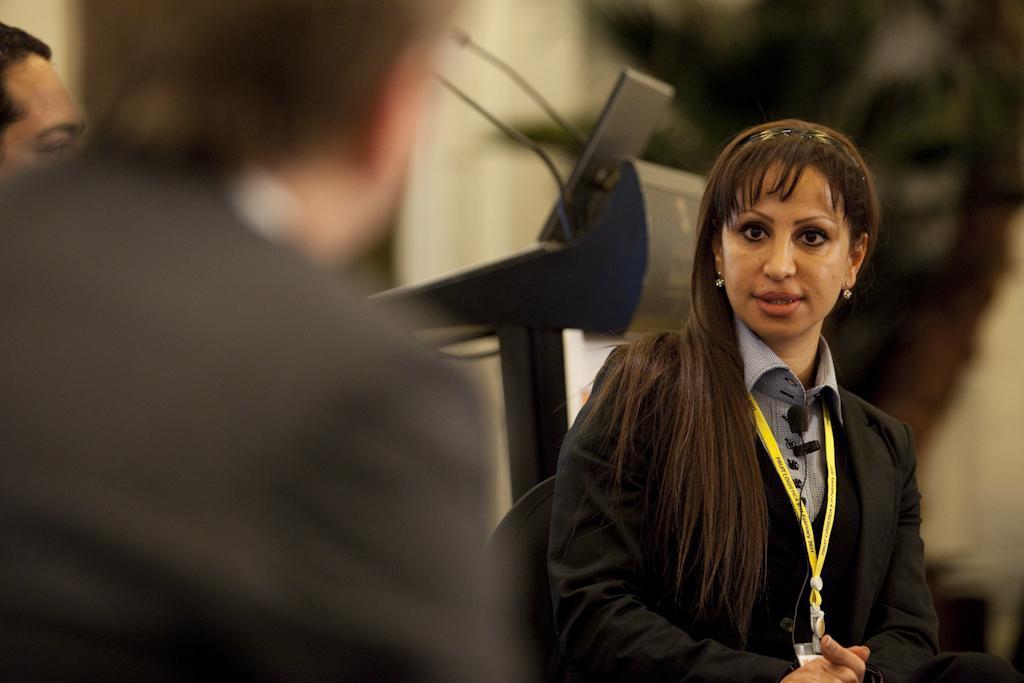Describe this image in one or two sentences. In this image we can see few people. A lady is wearing an identity card in the image. There is a podium and few microphones in the image. There is an object on the podium. There is a blur background in the image. 